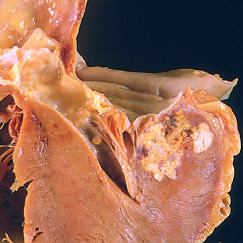one cusp has a partial fusion at whose center?
Answer the question using a single word or phrase. Its 